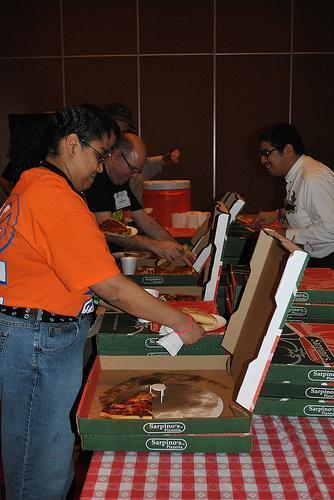How many people are on right side of table?
Give a very brief answer. 1. How many people are there?
Give a very brief answer. 4. How many pizza slices are in the box closest to the camera?
Give a very brief answer. 1. 